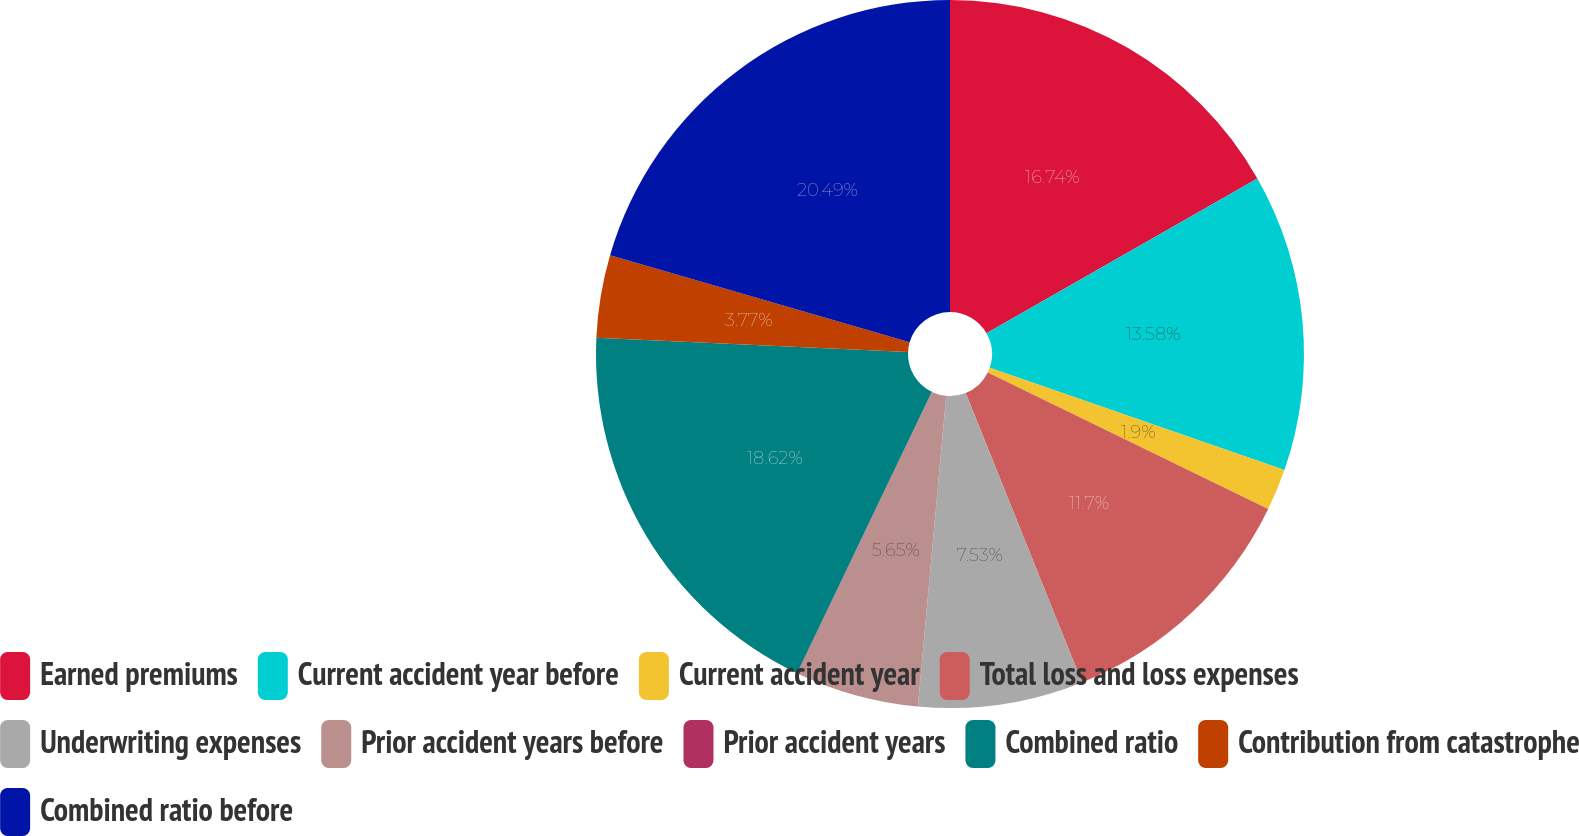<chart> <loc_0><loc_0><loc_500><loc_500><pie_chart><fcel>Earned premiums<fcel>Current accident year before<fcel>Current accident year<fcel>Total loss and loss expenses<fcel>Underwriting expenses<fcel>Prior accident years before<fcel>Prior accident years<fcel>Combined ratio<fcel>Contribution from catastrophe<fcel>Combined ratio before<nl><fcel>16.74%<fcel>13.58%<fcel>1.9%<fcel>11.7%<fcel>7.53%<fcel>5.65%<fcel>0.02%<fcel>18.62%<fcel>3.77%<fcel>20.5%<nl></chart> 